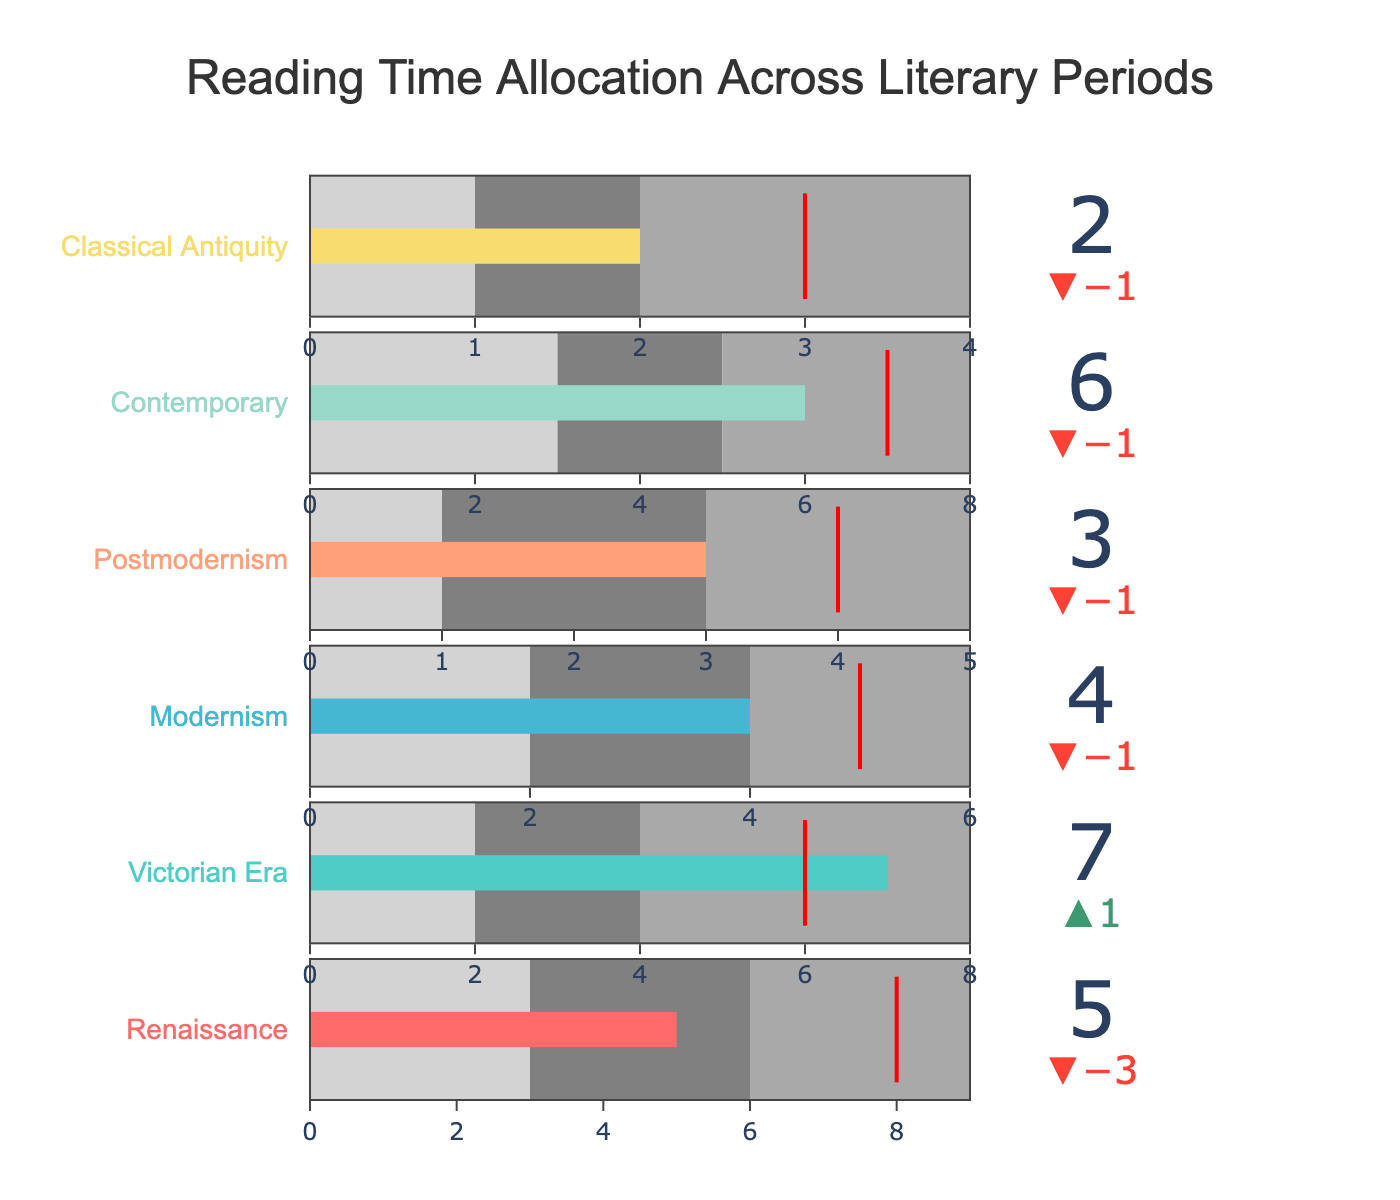How much reading time did you allocate to the Renaissance period? The "Actual" bar for the Renaissance period shows that the reading time allocated is marked at 5 units.
Answer: 5 What's the difference between the actual and target reading times for the Victorian Era? The actual reading time for the Victorian Era is 7 units, and the target is 6 units. The difference is calculated as 7 - 6.
Answer: 1 Which literary period has the lowest allocated reading time? By comparing the "Actual" bars for all periods, Classical Antiquity has the lowest reading time allocated, marked at 2 units.
Answer: Classical Antiquity What is the average of the actual reading times across all periods? Sum the actual reading times: 5 (Renaissance) + 7 (Victorian Era) + 4 (Modernism) + 3 (Postmodernism) + 6 (Contemporary) + 2 (Classical Antiquity) = 27. Then, divide by the number of periods: 27 / 6 = 4.5.
Answer: 4.5 Is the actual reading time for Postmodernism above or below its target? The actual reading time for Postmodernism is 3 units, while the target is 4 units. Since 3 < 4, it is below the target.
Answer: Below Which literary period exceeds its reading time target the most? The Victorian Era exceeds its target the most, with an actual time of 7 units and a target of 6 units, giving a difference of 1 unit.
Answer: Victorian Era How many periods have an actual reading time above their target? By comparing the actual and target times: 
- Renaissance: 5 vs 8 (below),
- Victorian Era: 7 vs 6 (above),
- Modernism: 4 vs 5 (below),
- Postmodernism: 3 vs 4 (below),
- Contemporary: 6 vs 7 (below),
- Classical Antiquity: 2 vs 3 (below).
Only the Victorian Era has an actual reading time above its target.
Answer: 1 What are the threshold values for the Modernism period? The threshold values are marked by the 'Range1,' 'Range2,' and 'Range3' columns: 2, 4, and 6 units respectively.
Answer: 2, 4, 6 Which period has the largest range in reading time allocation? The largest range is determined by the difference between 'Range3' and 'Range1':
- Renaissance: 9 - 3 = 6,
- Victorian Era: 8 - 2 = 6,
- Modernism: 6 - 2 = 4,
- Postmodernism: 5 - 1 = 4,
- Contemporary: 8 - 3 = 5,
- Classical Antiquity: 4 - 1 = 3.
The Renaissance and Victorian Era both have the largest range of 6 units.
Answer: Renaissance, Victorian Era 